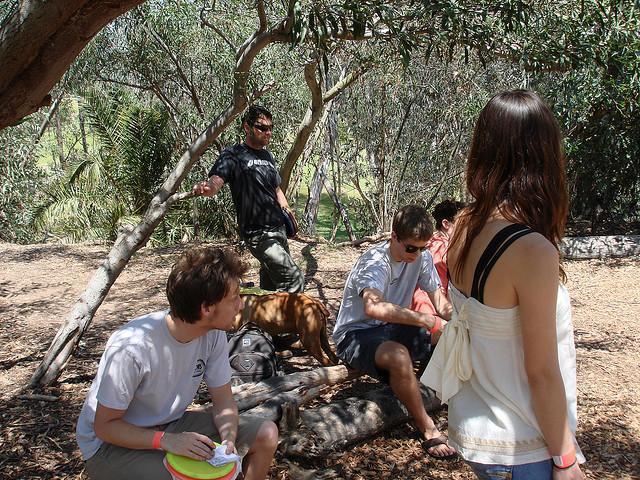How many men are in the picture?
Give a very brief answer. 3. How many people are there?
Give a very brief answer. 4. 